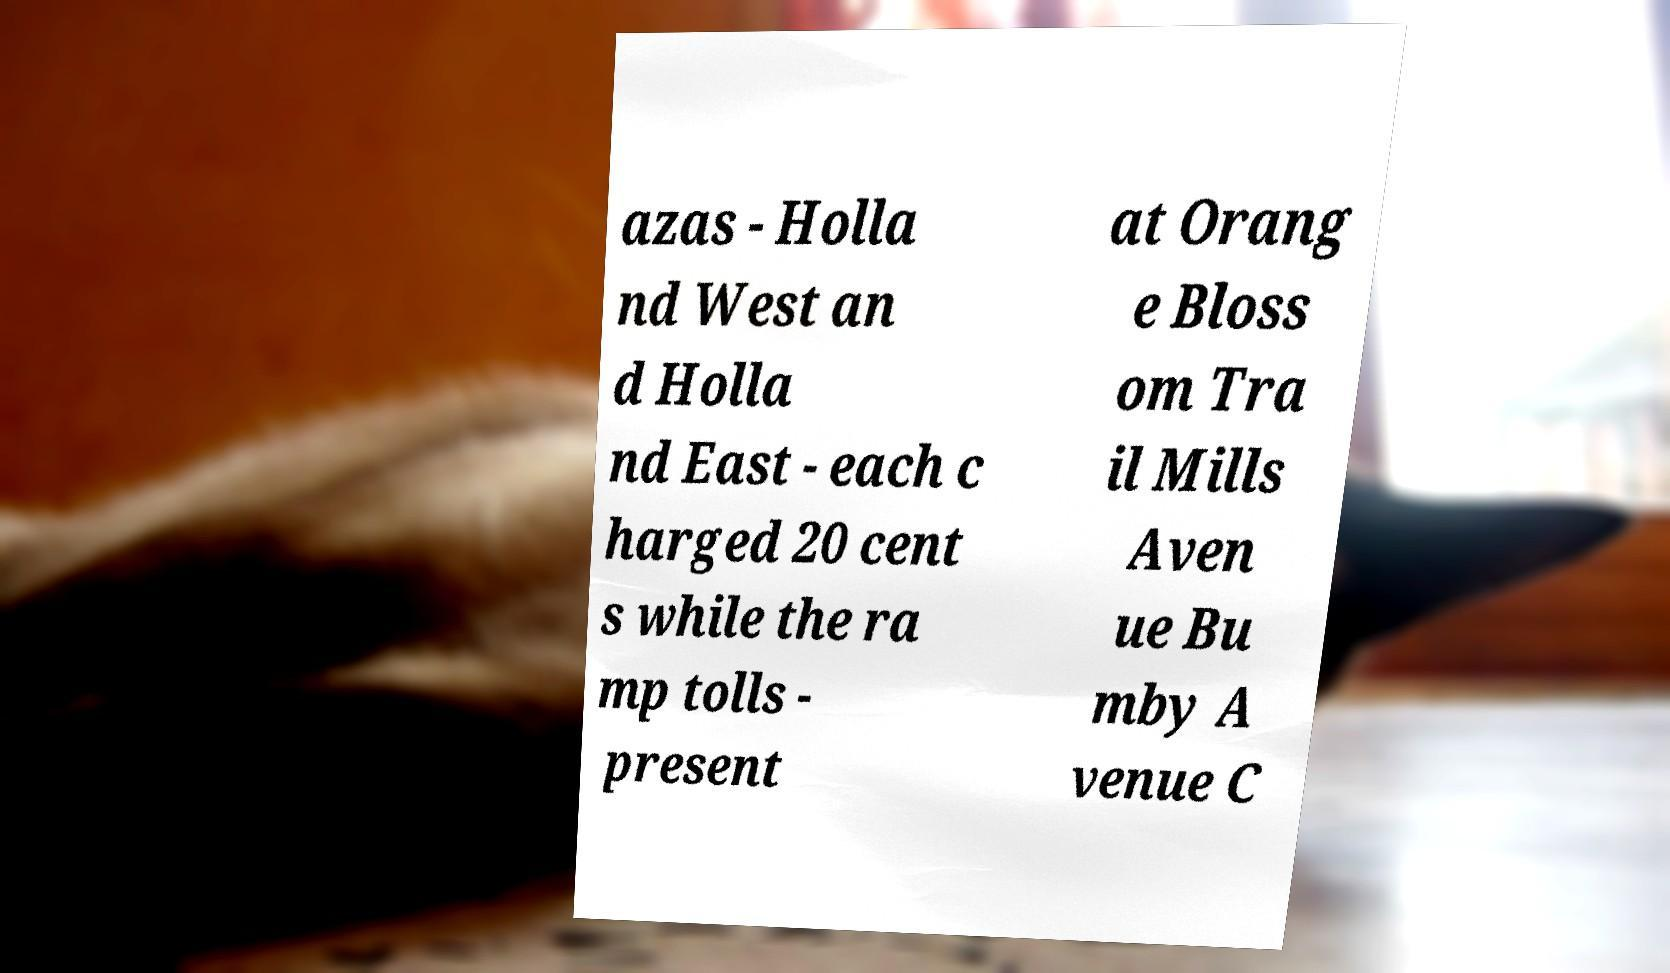Could you extract and type out the text from this image? azas - Holla nd West an d Holla nd East - each c harged 20 cent s while the ra mp tolls - present at Orang e Bloss om Tra il Mills Aven ue Bu mby A venue C 